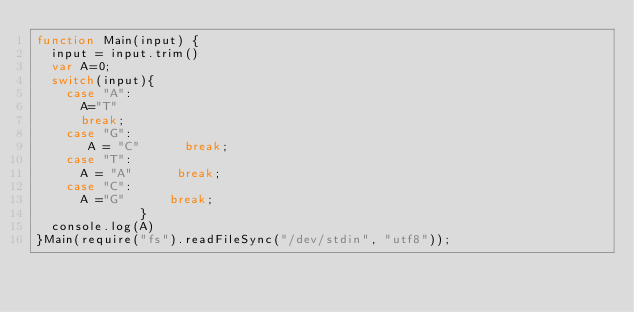<code> <loc_0><loc_0><loc_500><loc_500><_JavaScript_>function Main(input) {
  input = input.trim()
  var A=0;
  switch(input){
    case "A":
      A="T"
      break;
    case "G":
       A = "C"      break;
    case "T":
      A = "A"      break;
    case "C":
      A ="G"      break;
              }
  console.log(A)
}Main(require("fs").readFileSync("/dev/stdin", "utf8"));</code> 